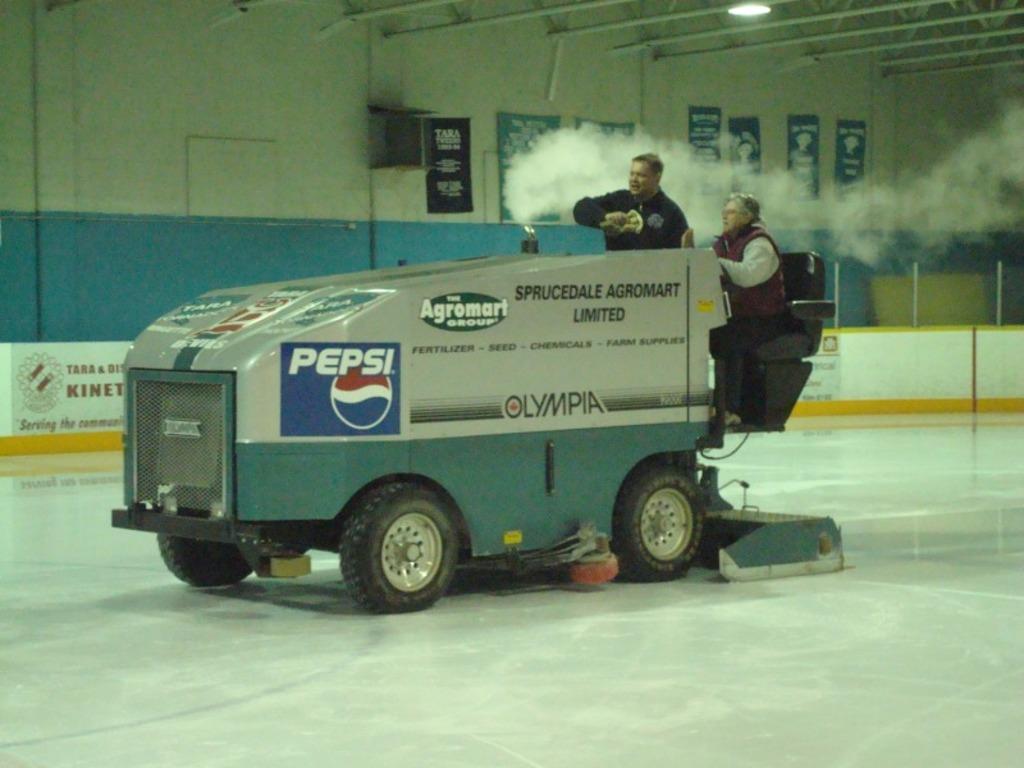In one or two sentences, can you explain what this image depicts? In this image we can see two persons sitting in a vehicle placed on the floor. In the background, we can see group of posters with text on the wall, group of poles, lights, signboard with some text and logo. 